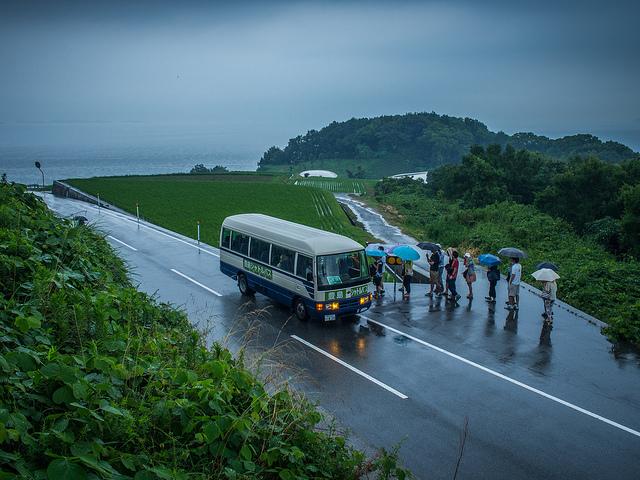Is it raining?
Quick response, please. Yes. What body of water is in the background?
Answer briefly. Ocean. What color is the bus on the right?
Write a very short answer. White. What kind of vehicle is visible?
Quick response, please. Bus. Is this in US?
Give a very brief answer. No. What are the people holding?
Answer briefly. Umbrellas. Is this a two lane highway?
Be succinct. Yes. What modes of transportation are visible in the photo?
Be succinct. Bus. Why are these people standing in a crowd?
Quick response, please. Waiting for bus. 